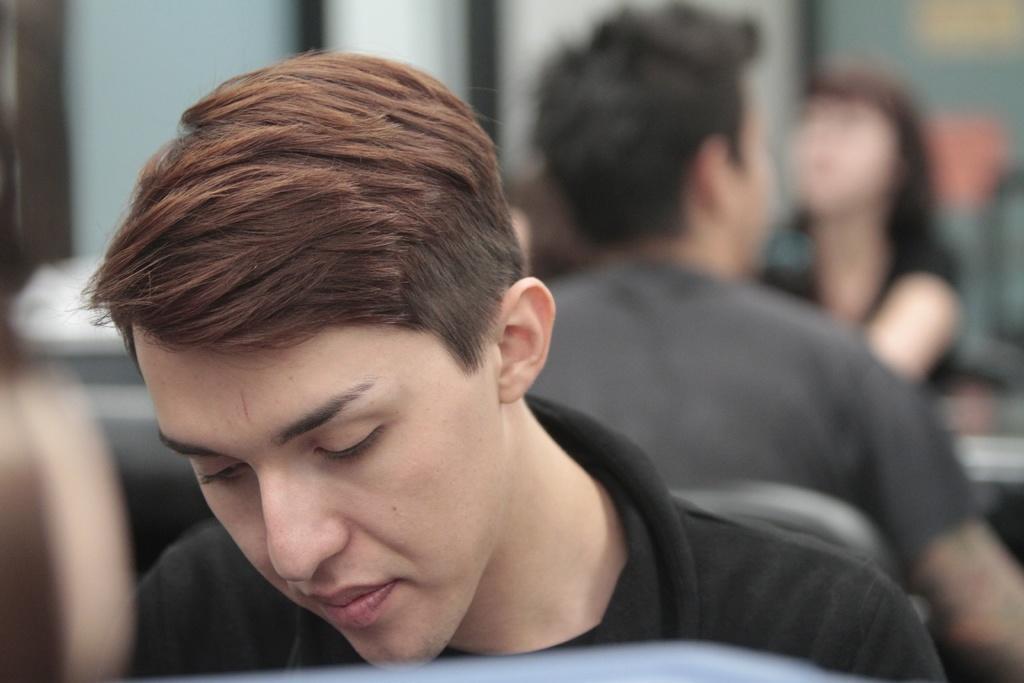Can you describe this image briefly? In this image there are two men seated on chairs behind each other, and there is a woman seated on the chair in front of one of the men. 